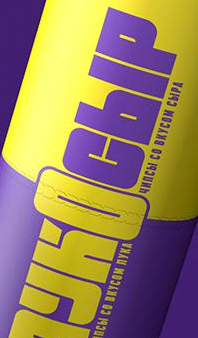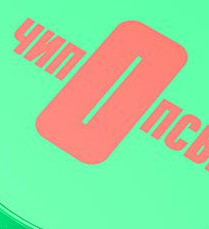What words are shown in these images in order, separated by a semicolon? YKOCbIP; nOnC 